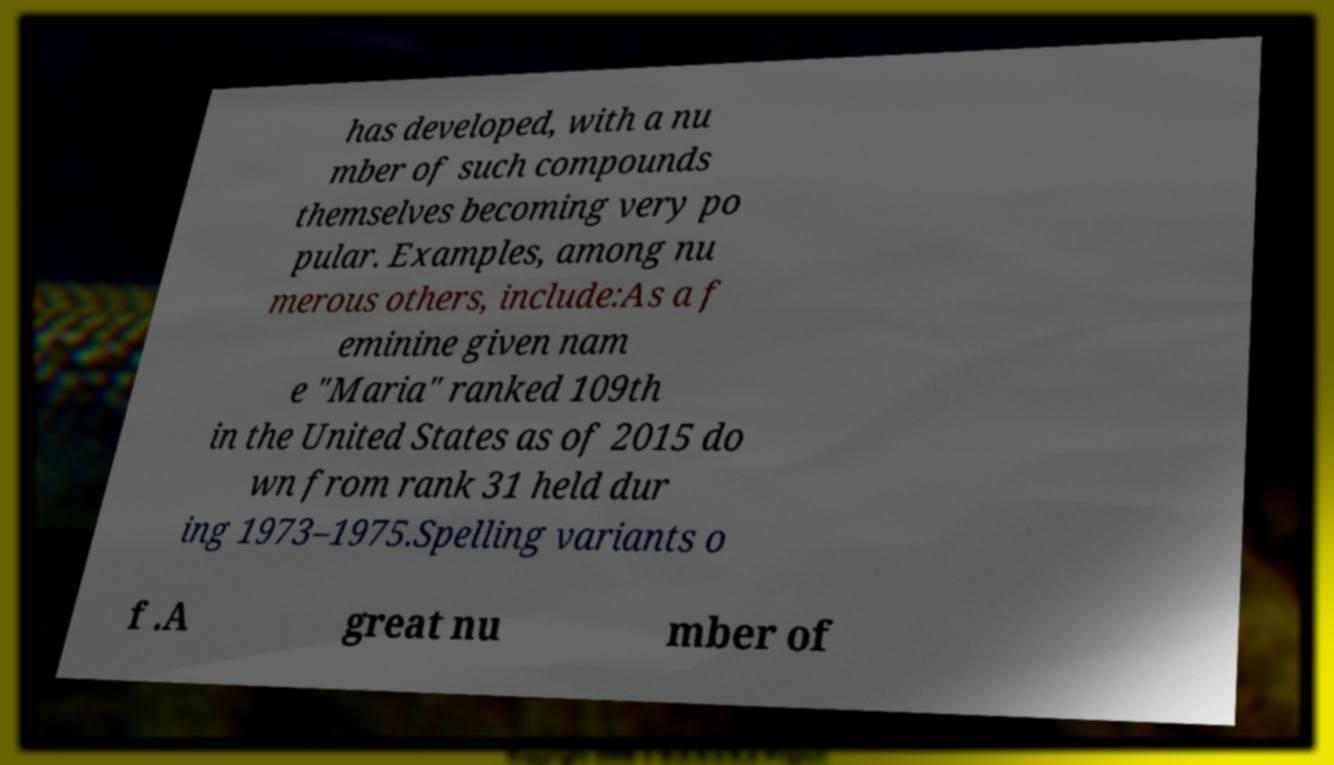There's text embedded in this image that I need extracted. Can you transcribe it verbatim? has developed, with a nu mber of such compounds themselves becoming very po pular. Examples, among nu merous others, include:As a f eminine given nam e "Maria" ranked 109th in the United States as of 2015 do wn from rank 31 held dur ing 1973–1975.Spelling variants o f .A great nu mber of 